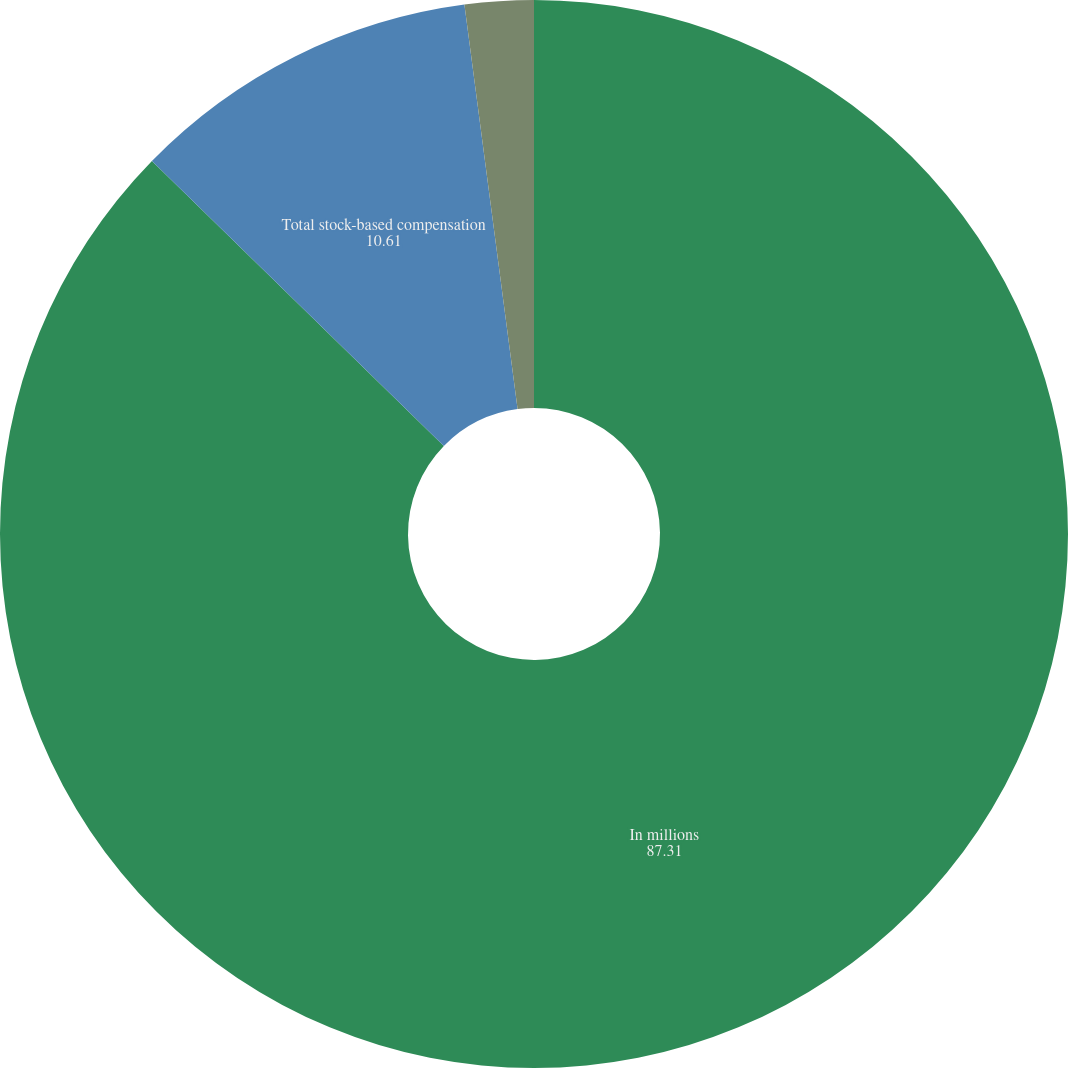Convert chart. <chart><loc_0><loc_0><loc_500><loc_500><pie_chart><fcel>In millions<fcel>Total stock-based compensation<fcel>Income tax benefits related to<nl><fcel>87.31%<fcel>10.61%<fcel>2.08%<nl></chart> 